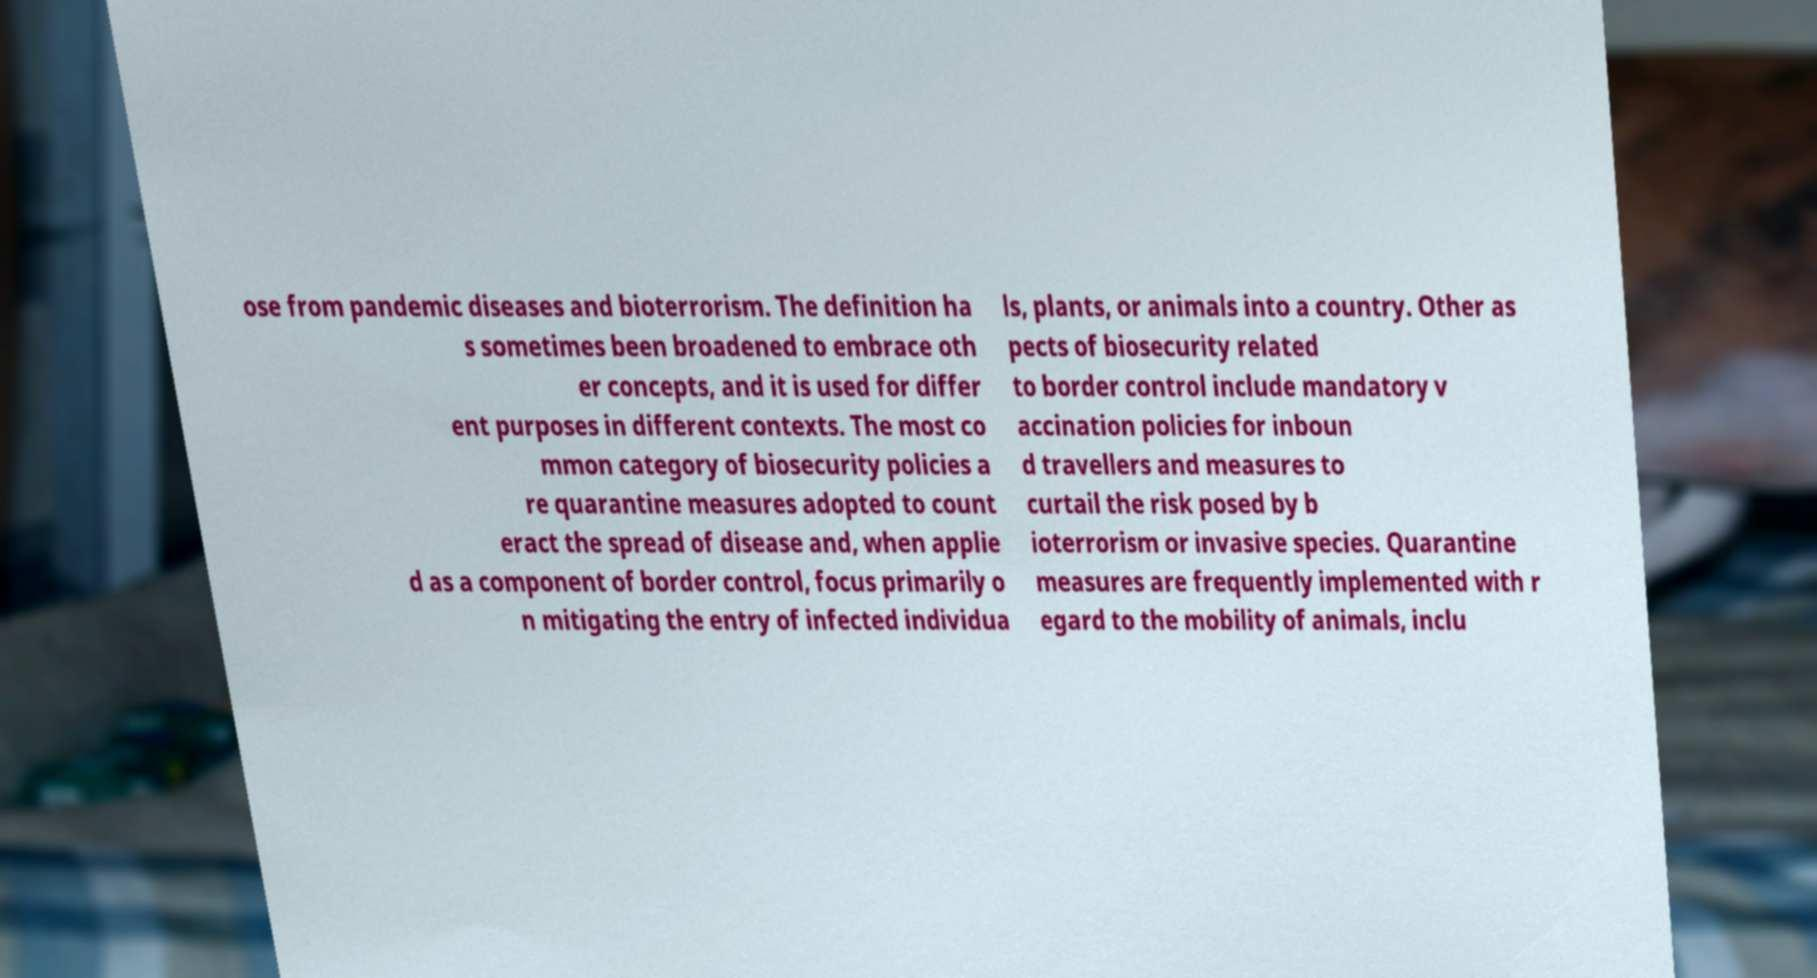What messages or text are displayed in this image? I need them in a readable, typed format. ose from pandemic diseases and bioterrorism. The definition ha s sometimes been broadened to embrace oth er concepts, and it is used for differ ent purposes in different contexts. The most co mmon category of biosecurity policies a re quarantine measures adopted to count eract the spread of disease and, when applie d as a component of border control, focus primarily o n mitigating the entry of infected individua ls, plants, or animals into a country. Other as pects of biosecurity related to border control include mandatory v accination policies for inboun d travellers and measures to curtail the risk posed by b ioterrorism or invasive species. Quarantine measures are frequently implemented with r egard to the mobility of animals, inclu 